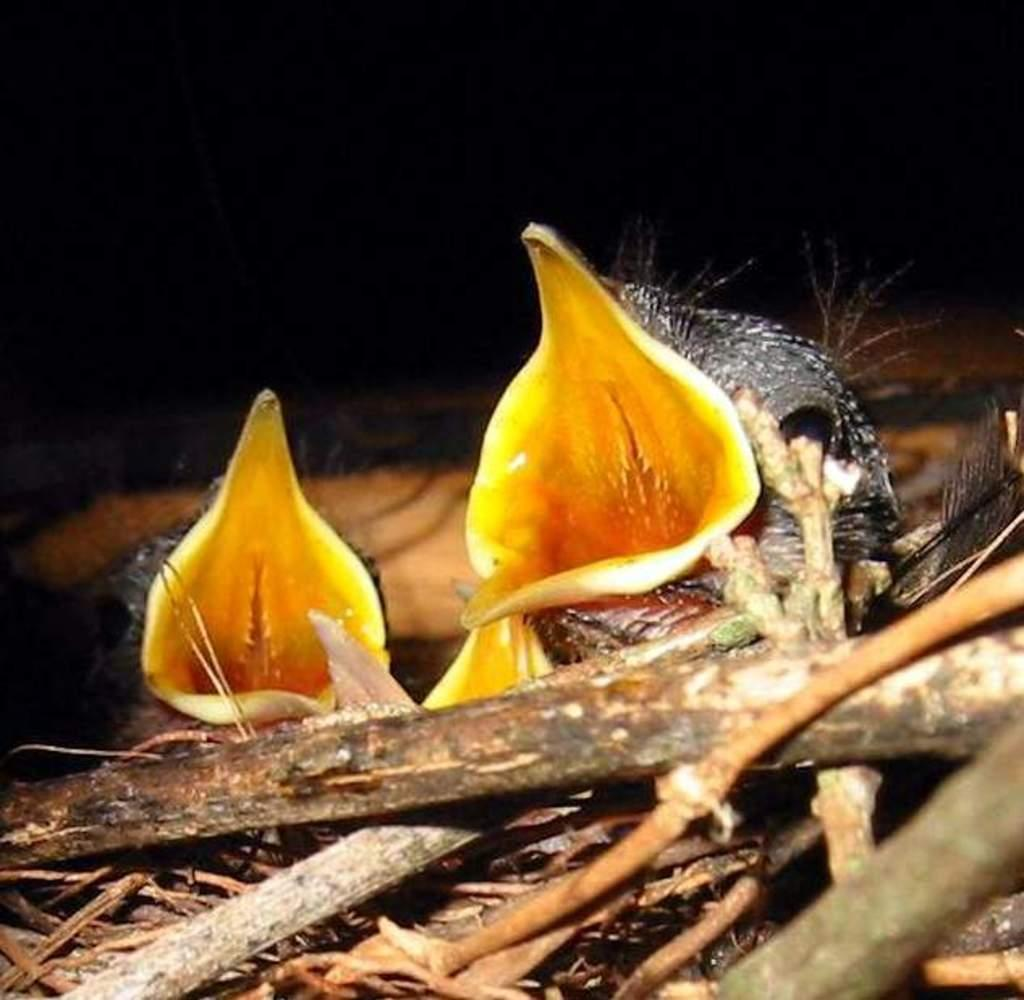What type of animals can be seen in the image? Birds can be seen in the image. Where are the birds situated in the image? The birds are in a nest. What type of border is surrounding the nest in the image? There is no border surrounding the nest in the image. How do the birds in the nest show respect to each other? The image does not depict any behavior or interaction between the birds, so it cannot be determined how they might show respect to each other. 